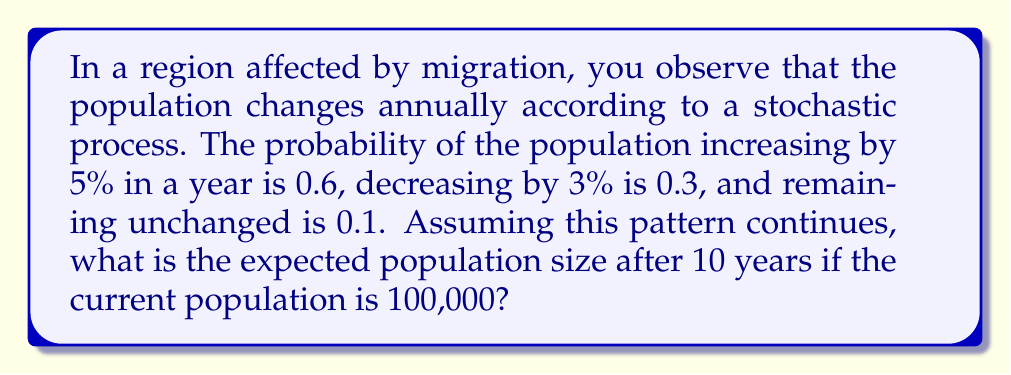Show me your answer to this math problem. Let's approach this step-by-step using the concept of expected value and compound growth:

1) First, let's calculate the expected annual growth rate:
   $E(\text{growth rate}) = 0.6 \cdot 1.05 + 0.3 \cdot 0.97 + 0.1 \cdot 1 = 1.022$

2) This means that, on average, the population is expected to grow by 2.2% each year.

3) To find the expected population after 10 years, we can use the compound growth formula:
   $E(\text{Population after 10 years}) = 100,000 \cdot (1.022)^{10}$

4) Using a calculator or computing software:
   $100,000 \cdot (1.022)^{10} \approx 124,508.27$

5) Since we're dealing with a population, we round to the nearest whole number.

Therefore, the expected population size after 10 years is approximately 124,508 people.
Answer: 124,508 people 